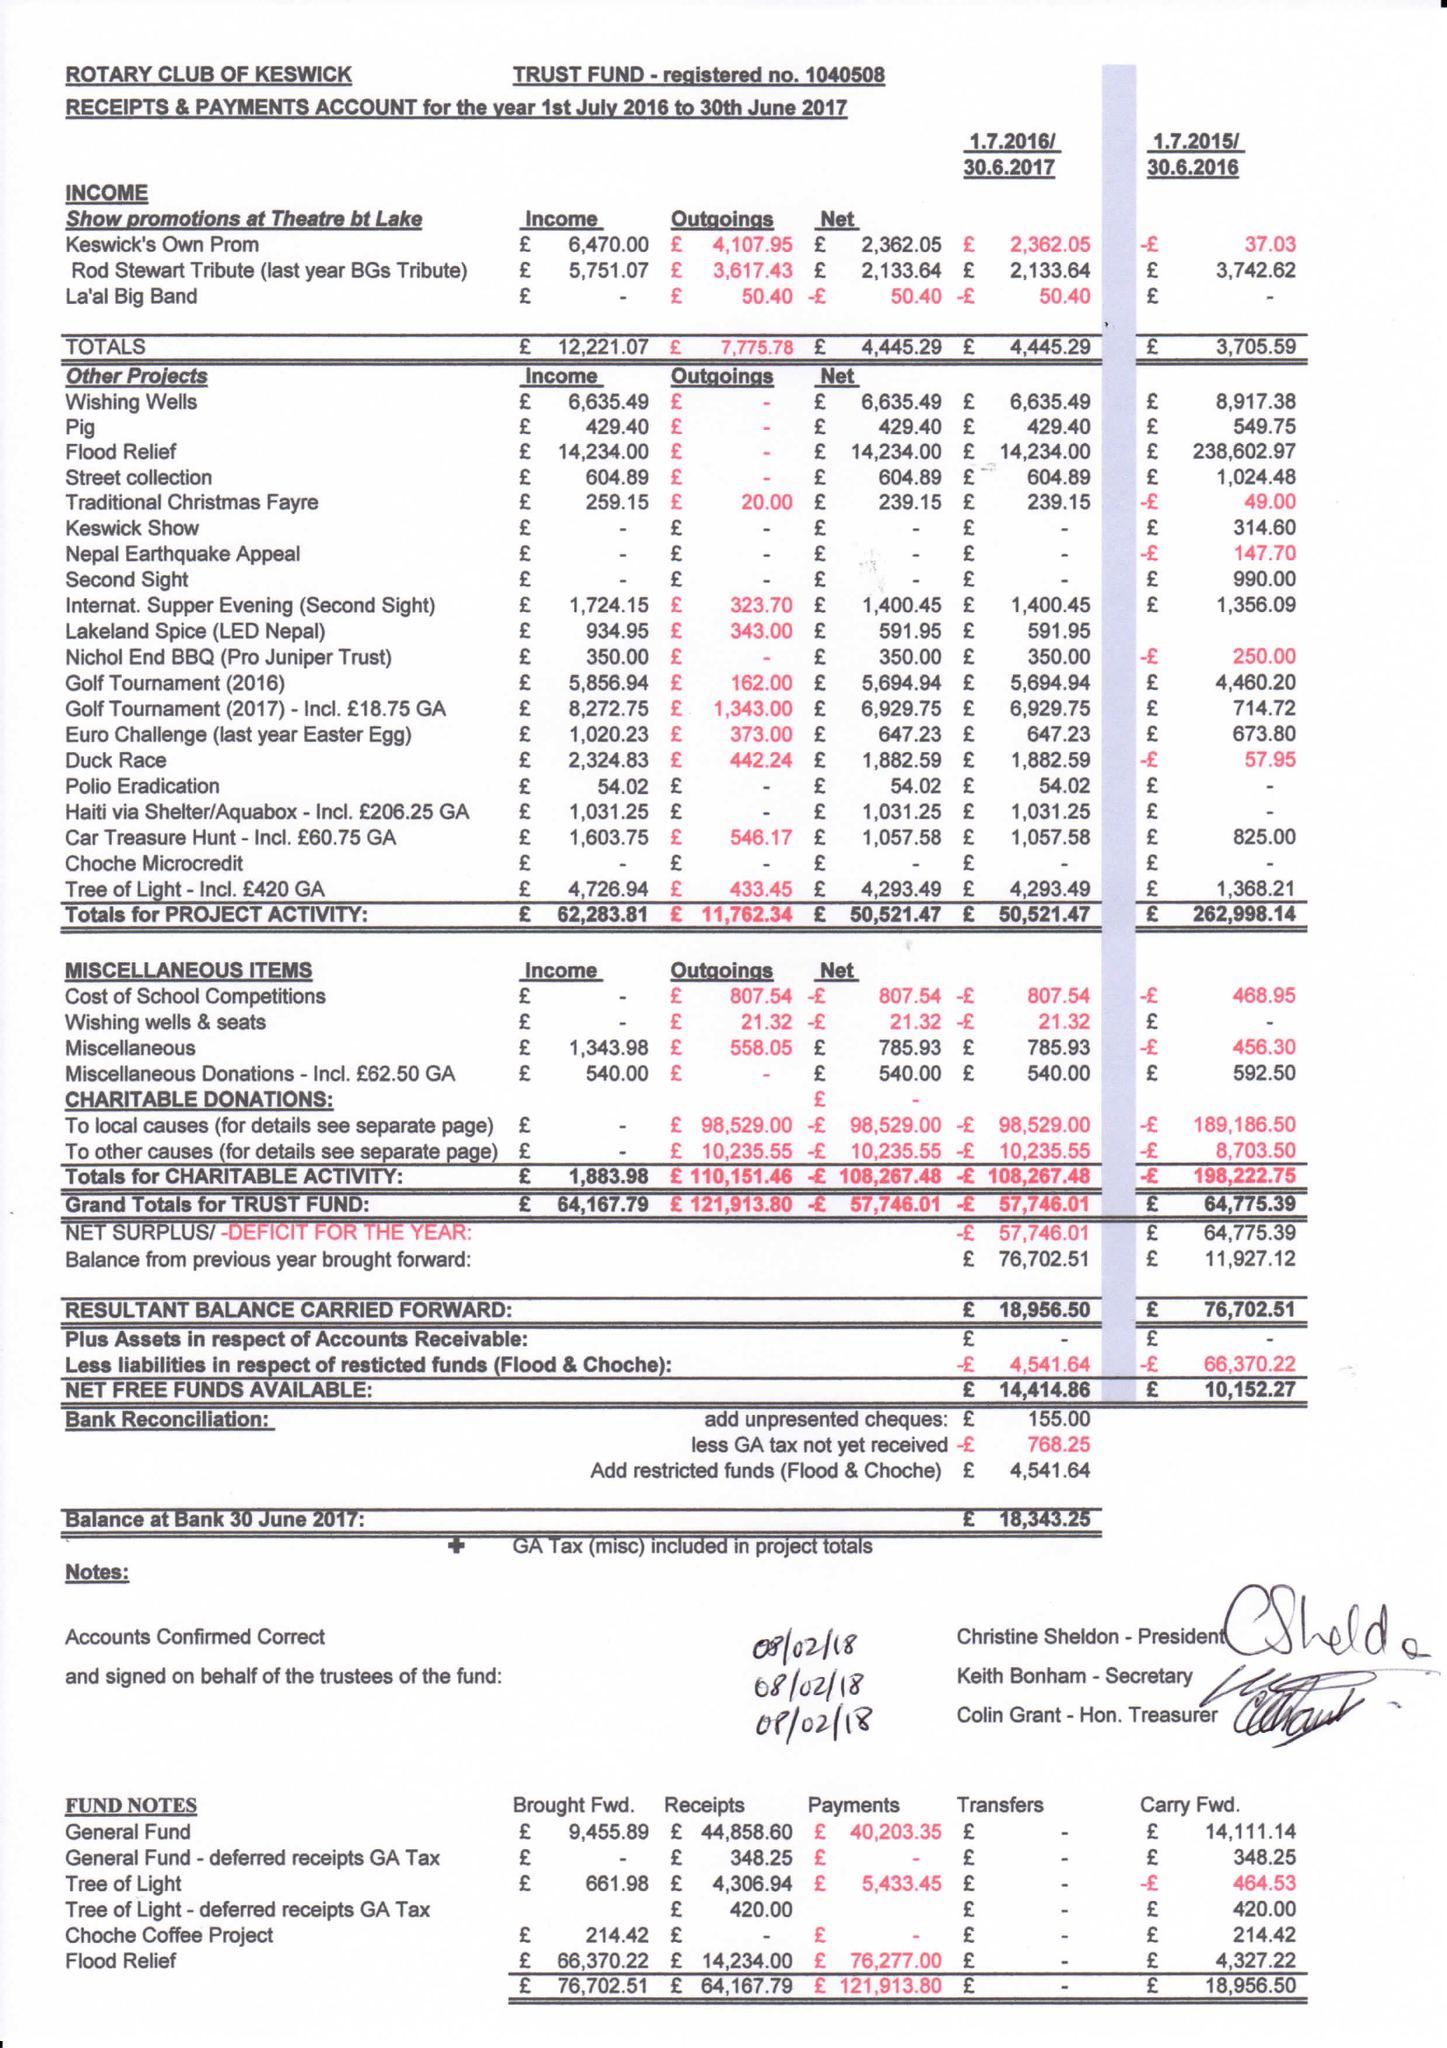What is the value for the income_annually_in_british_pounds?
Answer the question using a single word or phrase. 64168.00 